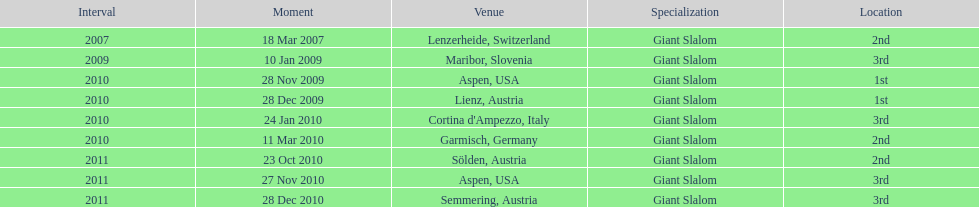How many races were in 2010? 5. 